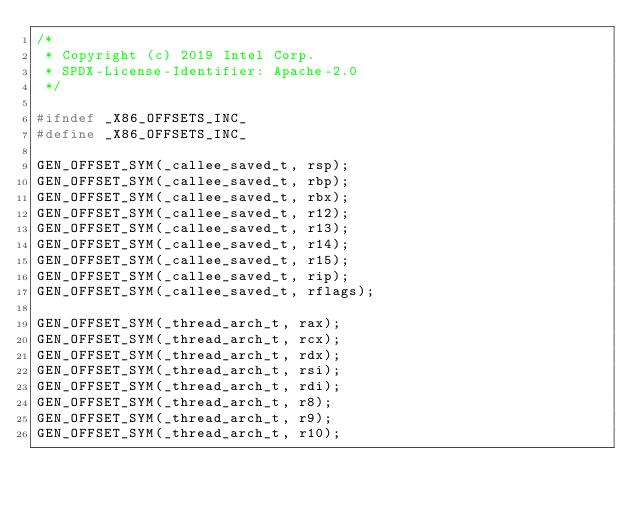Convert code to text. <code><loc_0><loc_0><loc_500><loc_500><_C_>/*
 * Copyright (c) 2019 Intel Corp.
 * SPDX-License-Identifier: Apache-2.0
 */

#ifndef _X86_OFFSETS_INC_
#define _X86_OFFSETS_INC_

GEN_OFFSET_SYM(_callee_saved_t, rsp);
GEN_OFFSET_SYM(_callee_saved_t, rbp);
GEN_OFFSET_SYM(_callee_saved_t, rbx);
GEN_OFFSET_SYM(_callee_saved_t, r12);
GEN_OFFSET_SYM(_callee_saved_t, r13);
GEN_OFFSET_SYM(_callee_saved_t, r14);
GEN_OFFSET_SYM(_callee_saved_t, r15);
GEN_OFFSET_SYM(_callee_saved_t, rip);
GEN_OFFSET_SYM(_callee_saved_t, rflags);

GEN_OFFSET_SYM(_thread_arch_t, rax);
GEN_OFFSET_SYM(_thread_arch_t, rcx);
GEN_OFFSET_SYM(_thread_arch_t, rdx);
GEN_OFFSET_SYM(_thread_arch_t, rsi);
GEN_OFFSET_SYM(_thread_arch_t, rdi);
GEN_OFFSET_SYM(_thread_arch_t, r8);
GEN_OFFSET_SYM(_thread_arch_t, r9);
GEN_OFFSET_SYM(_thread_arch_t, r10);</code> 